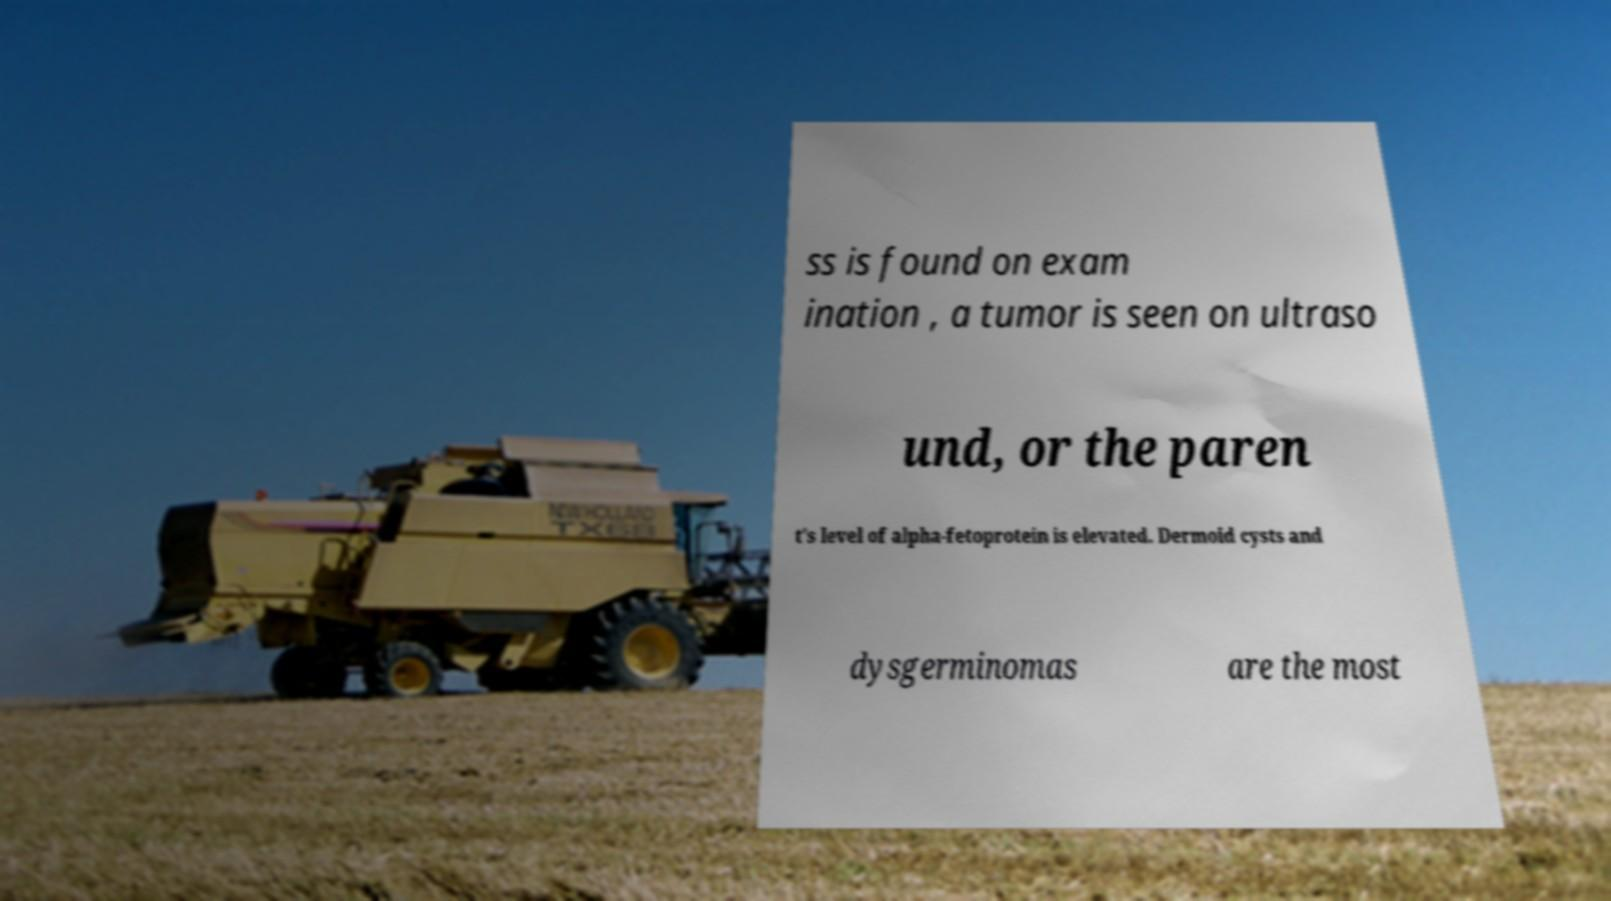Please read and relay the text visible in this image. What does it say? ss is found on exam ination , a tumor is seen on ultraso und, or the paren t's level of alpha-fetoprotein is elevated. Dermoid cysts and dysgerminomas are the most 